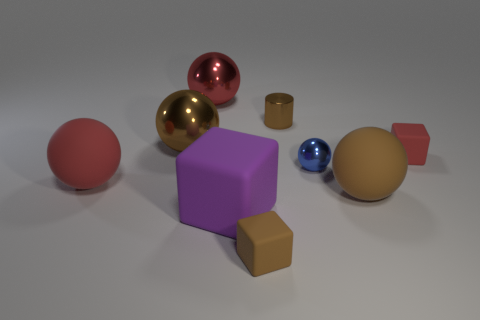Subtract all purple blocks. How many blocks are left? 2 Add 1 large red rubber spheres. How many objects exist? 10 Subtract all spheres. How many objects are left? 4 Subtract all brown cubes. How many cubes are left? 2 Subtract all purple cylinders. How many brown spheres are left? 2 Subtract all big brown things. Subtract all large purple rubber blocks. How many objects are left? 6 Add 2 matte spheres. How many matte spheres are left? 4 Add 7 small blue balls. How many small blue balls exist? 8 Subtract 0 blue cubes. How many objects are left? 9 Subtract 5 balls. How many balls are left? 0 